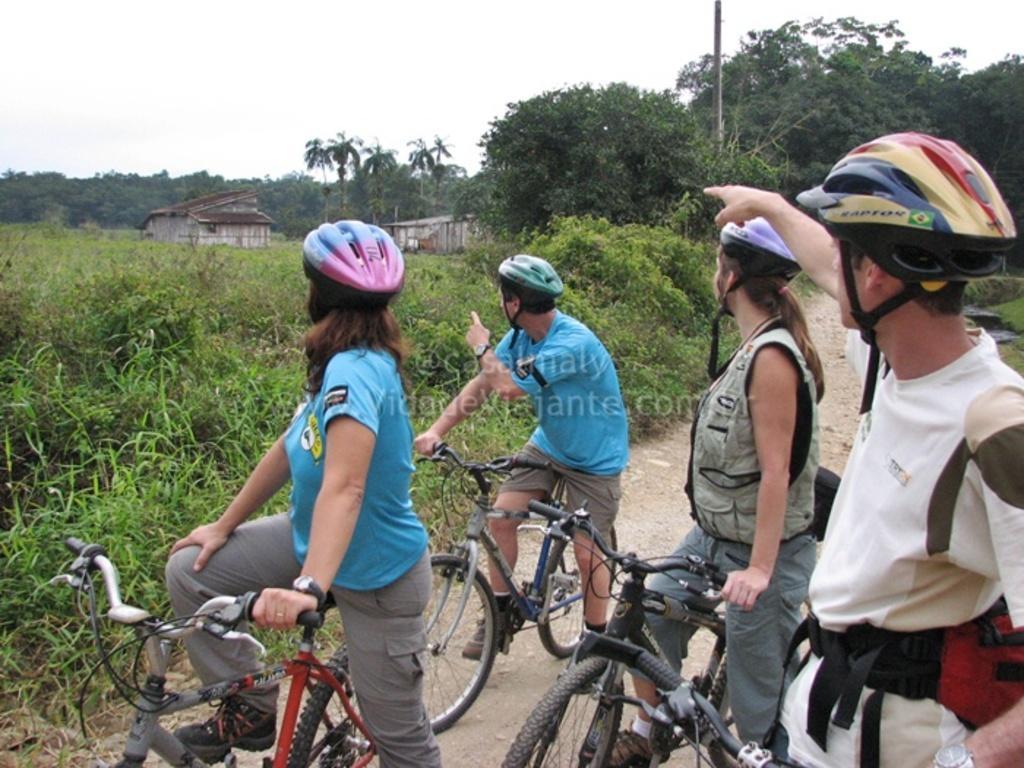Describe this image in one or two sentences. In this image i can see 4 persons on the bicycles, each of them is wearing a helmet, on the background i can see plants, houses, electric pole and sky. 